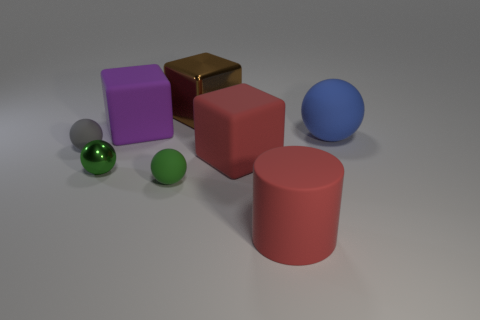Is the number of gray objects that are behind the big brown thing the same as the number of green rubber things right of the green metal thing?
Provide a short and direct response. No. What number of tiny brown cylinders have the same material as the big blue thing?
Ensure brevity in your answer.  0. What shape is the thing that is the same color as the metallic sphere?
Offer a terse response. Sphere. There is a metal object that is on the left side of the small green object that is right of the tiny green metallic ball; how big is it?
Offer a very short reply. Small. There is a big object in front of the metallic ball; is its shape the same as the green object behind the tiny green rubber sphere?
Offer a very short reply. No. Is the number of large spheres in front of the green shiny object the same as the number of blue balls?
Offer a terse response. No. The other rubber thing that is the same shape as the big purple thing is what color?
Make the answer very short. Red. Do the large block in front of the blue rubber object and the brown object have the same material?
Give a very brief answer. No. How many small things are gray rubber cylinders or gray matte balls?
Offer a very short reply. 1. How big is the purple object?
Your answer should be compact. Large. 